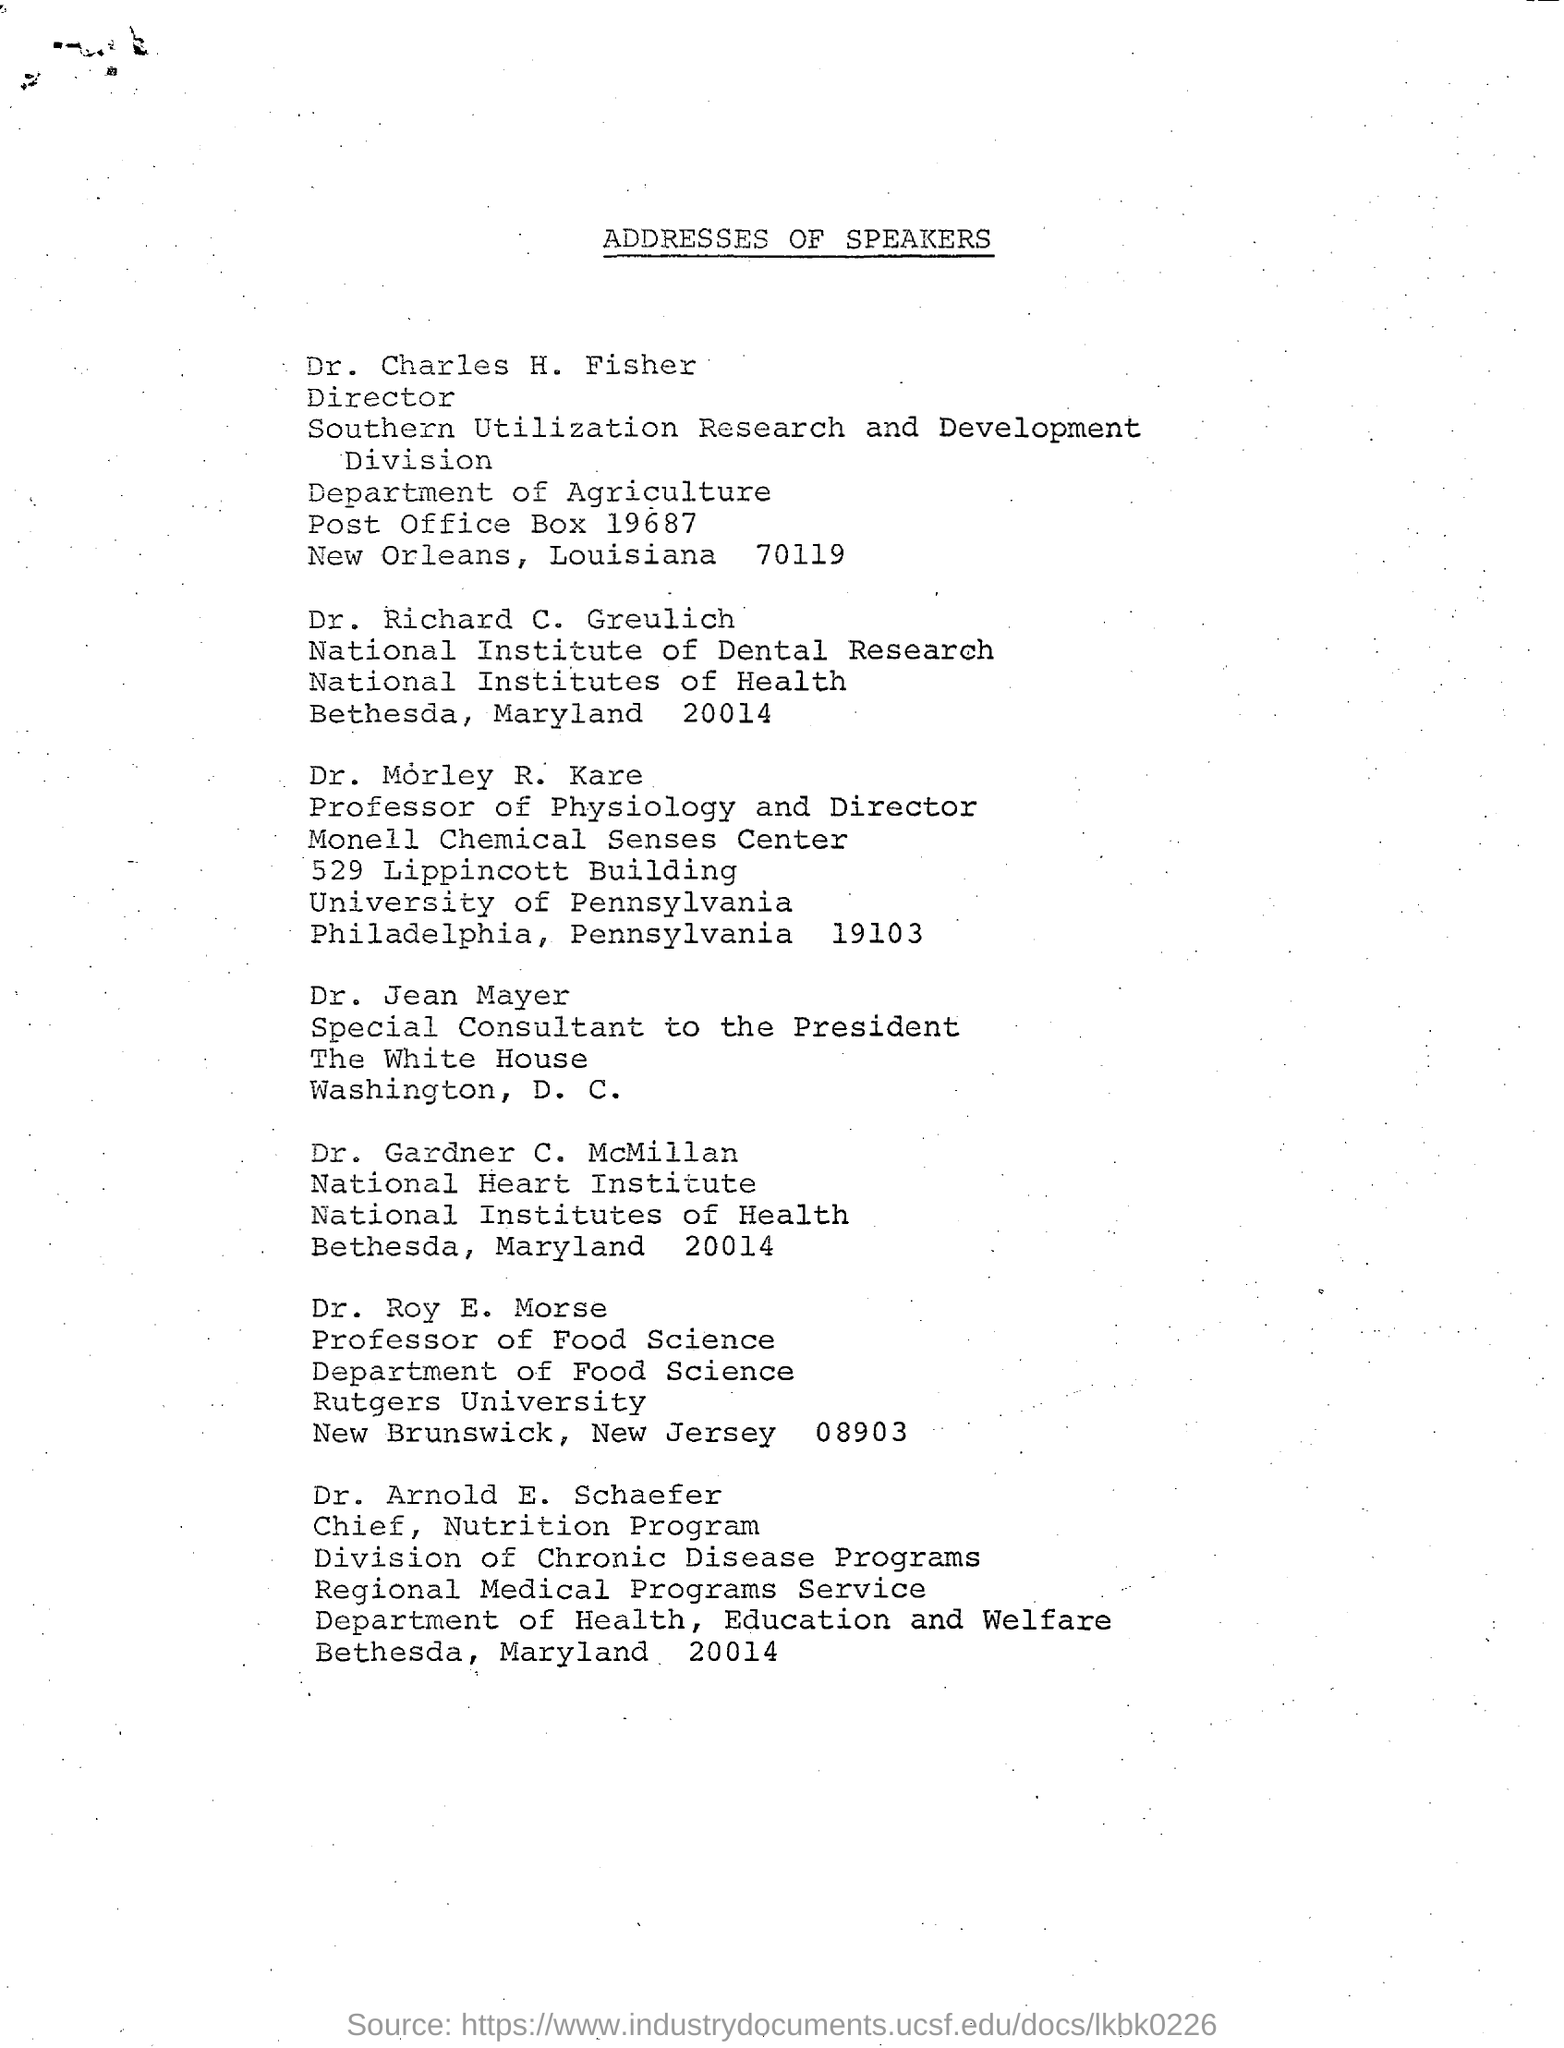Highlight a few significant elements in this photo. The title of the document is "Addresses of Speakers. Dr. Jean Mayer holds the designation of special consultant to the president. Roy E. Morse holds the designation of Professor of Food Science. 